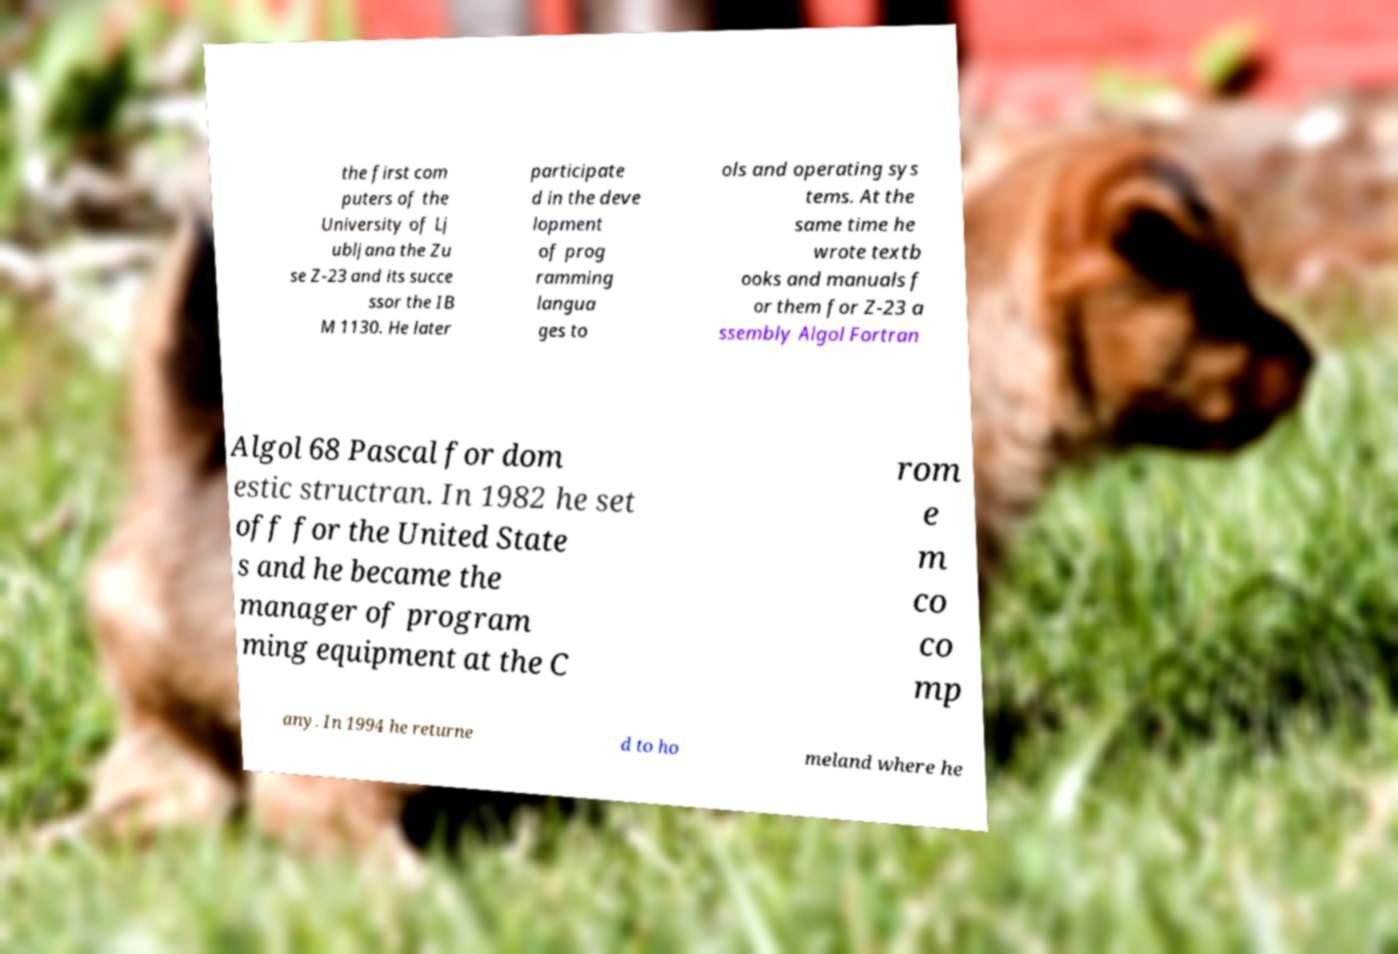Please read and relay the text visible in this image. What does it say? the first com puters of the University of Lj ubljana the Zu se Z-23 and its succe ssor the IB M 1130. He later participate d in the deve lopment of prog ramming langua ges to ols and operating sys tems. At the same time he wrote textb ooks and manuals f or them for Z-23 a ssembly Algol Fortran Algol 68 Pascal for dom estic structran. In 1982 he set off for the United State s and he became the manager of program ming equipment at the C rom e m co co mp any. In 1994 he returne d to ho meland where he 